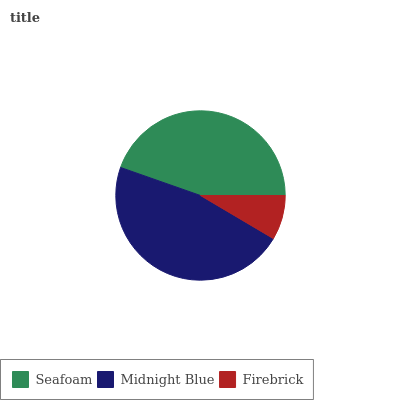Is Firebrick the minimum?
Answer yes or no. Yes. Is Midnight Blue the maximum?
Answer yes or no. Yes. Is Midnight Blue the minimum?
Answer yes or no. No. Is Firebrick the maximum?
Answer yes or no. No. Is Midnight Blue greater than Firebrick?
Answer yes or no. Yes. Is Firebrick less than Midnight Blue?
Answer yes or no. Yes. Is Firebrick greater than Midnight Blue?
Answer yes or no. No. Is Midnight Blue less than Firebrick?
Answer yes or no. No. Is Seafoam the high median?
Answer yes or no. Yes. Is Seafoam the low median?
Answer yes or no. Yes. Is Midnight Blue the high median?
Answer yes or no. No. Is Midnight Blue the low median?
Answer yes or no. No. 